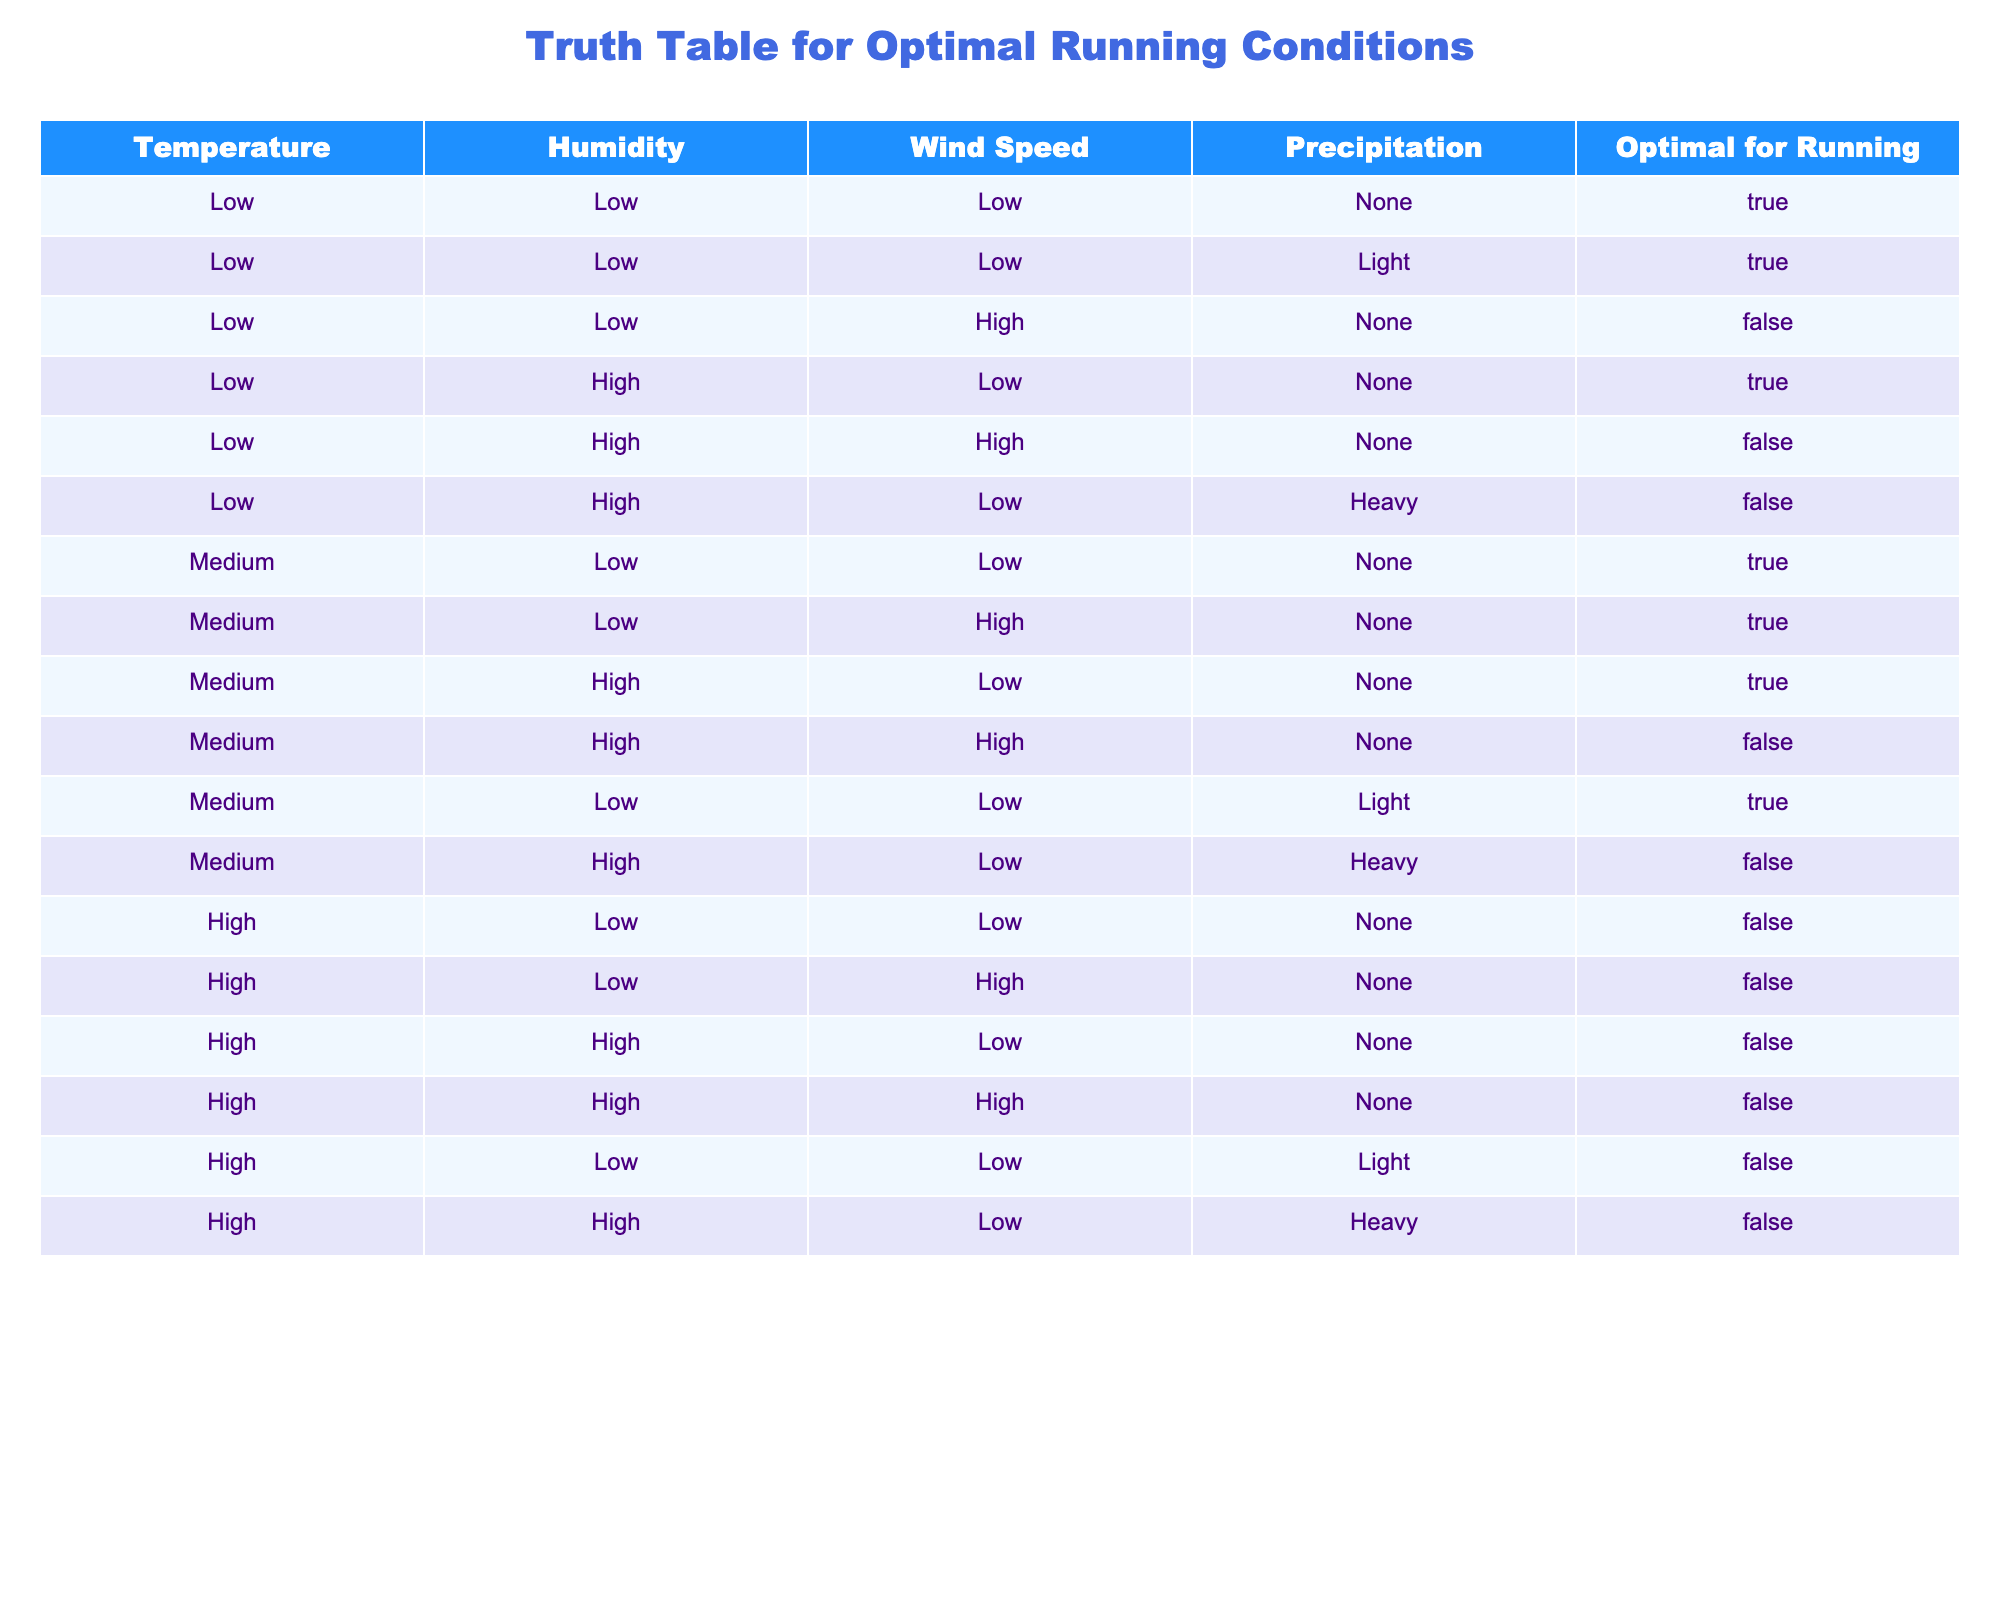What is the optimal running condition when the temperature is low, humidity is high, and wind speed is low? Referring to the row with the conditions of low temperature, high humidity, and low wind speed, it states that the optimal for running is True.
Answer: True How many conditions are labeled as optimal for running in the table? By counting the rows where the ‘Optimal for Running’ column shows True, there are 7 instances of optimal running conditions.
Answer: 7 Is running optimal if the temperature is high and there is heavy precipitation? Looking at the row with high temperature and heavy precipitation, it shows that the condition is not optimal (False).
Answer: False What is the total number of conditions categorized as low wind speed? We need to filter the table for rows where the wind speed is low. There are 8 occurrences of low wind speed across various weather conditions.
Answer: 8 If the temperature is medium and humidity is low, how many conditions are optimal for running? Checking the rows where the temperature is medium and humidity is low, we see that 3 conditions (with different wind speeds and precipitation) are marked as optimal for running.
Answer: 3 What is the total number of conditions that are not optimal for running? By counting the rows where 'Optimal for Running' is False, we determine there are 9 conditions that are not optimal for running.
Answer: 9 When both temperature and humidity are high, is it always optimal for running? In the rows where temperature is high and humidity is high, all expressed conditions indicate it is not optimal (False). This includes instances of low and high wind speeds.
Answer: No How many running conditions are optimal if the temperature is medium? Analyzing the medium temperature rows, there are 5 conditions labeled as optimal for running.
Answer: 5 